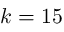Convert formula to latex. <formula><loc_0><loc_0><loc_500><loc_500>k = 1 5</formula> 